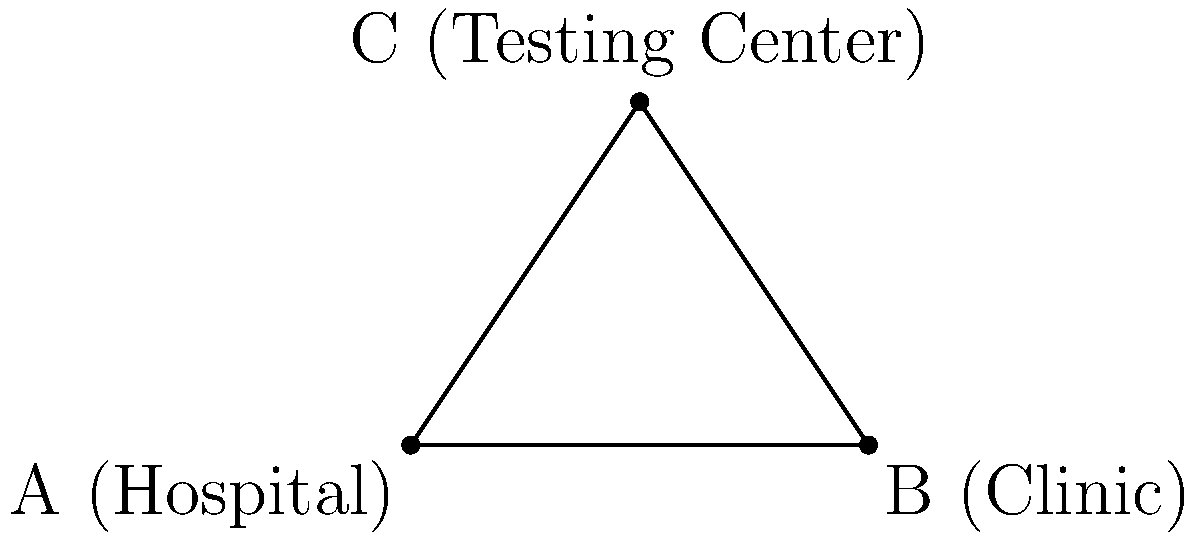In a community health planning project, you are tasked with optimizing resource distribution between three healthcare facilities: a hospital (A), a clinic (B), and a testing center (C). The hospital and clinic are 8 km apart, and the testing center is located 6 km from the clinic. If the line connecting the hospital to the testing center forms a right angle with the line between the hospital and clinic, what is the distance between the hospital and the testing center? Let's approach this step-by-step using the Pythagorean theorem:

1) We have a right triangle ABC, where:
   - A is the hospital
   - B is the clinic
   - C is the testing center
   - Angle ACB is a right angle (90°)

2) We know:
   - AB (distance between hospital and clinic) = 8 km
   - BC (distance between clinic and testing center) = 6 km

3) We need to find AC (distance between hospital and testing center)

4) Using the Pythagorean theorem: 
   $AC^2 + BC^2 = AB^2$

5) Substituting the known values:
   $AC^2 + 6^2 = 8^2$

6) Simplify:
   $AC^2 + 36 = 64$

7) Subtract 36 from both sides:
   $AC^2 = 28$

8) Take the square root of both sides:
   $AC = \sqrt{28}$

9) Simplify the square root:
   $AC = 2\sqrt{7}$ km

Therefore, the distance between the hospital and the testing center is $2\sqrt{7}$ km.
Answer: $2\sqrt{7}$ km 